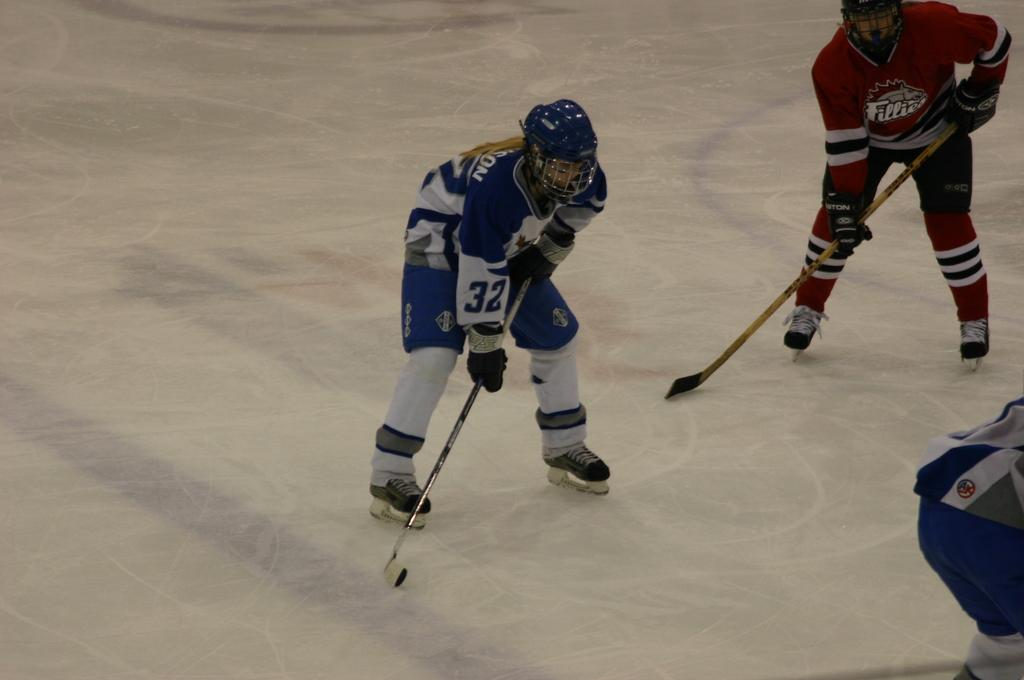What activity are the people in the image engaged in? The people in the image are playing. What type of clothing are the people wearing? The people are wearing clothes. What protective gear are the people wearing? The people are wearing helmets and gloves. What type of shoes are the people wearing? The people are wearing snow skiing shoes. What equipment can be seen in the image? There is a hockey stick in the image. What surface can be seen in the image? There is an ice surface in the image. What type of hose is being used to water the quince in the image? There is no hose or quince present in the image. The image features people playing on an ice surface with hockey equipment. 